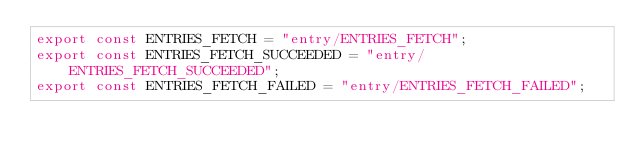Convert code to text. <code><loc_0><loc_0><loc_500><loc_500><_TypeScript_>export const ENTRIES_FETCH = "entry/ENTRIES_FETCH";
export const ENTRIES_FETCH_SUCCEEDED = "entry/ENTRIES_FETCH_SUCCEEDED";
export const ENTRIES_FETCH_FAILED = "entry/ENTRIES_FETCH_FAILED";</code> 